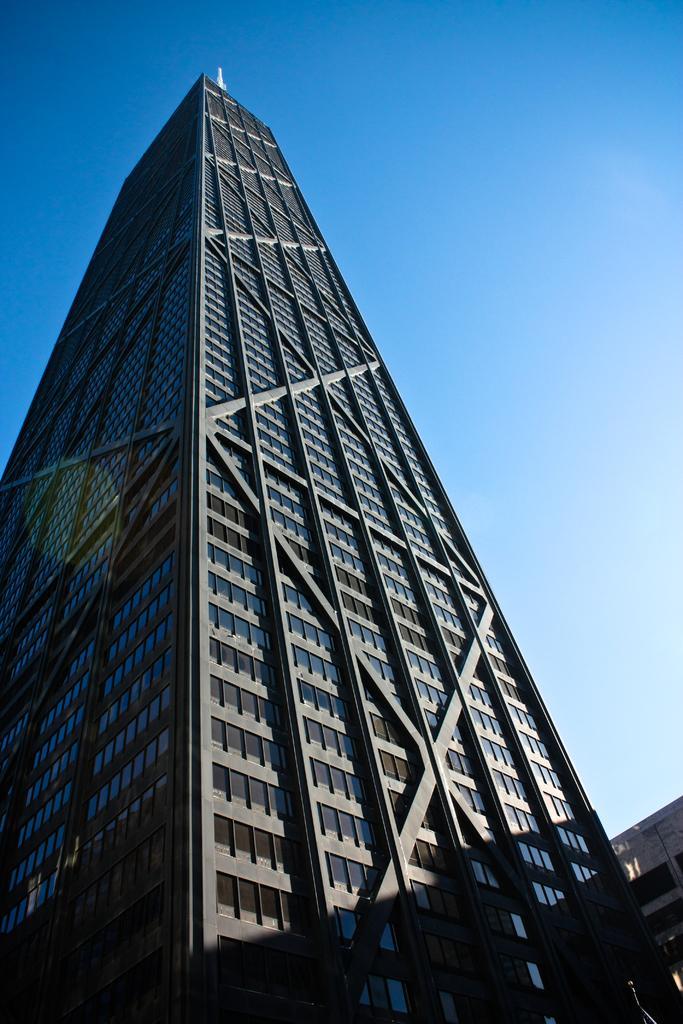Describe this image in one or two sentences. In this image I can see few buildings and windows. The sky is in blue and white color. 